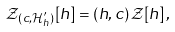<formula> <loc_0><loc_0><loc_500><loc_500>\mathcal { Z } _ { ( c , \mathcal { H } _ { h } ^ { \prime } ) } [ h ] = ( h , c ) \, \mathcal { Z } [ h ] \, ,</formula> 